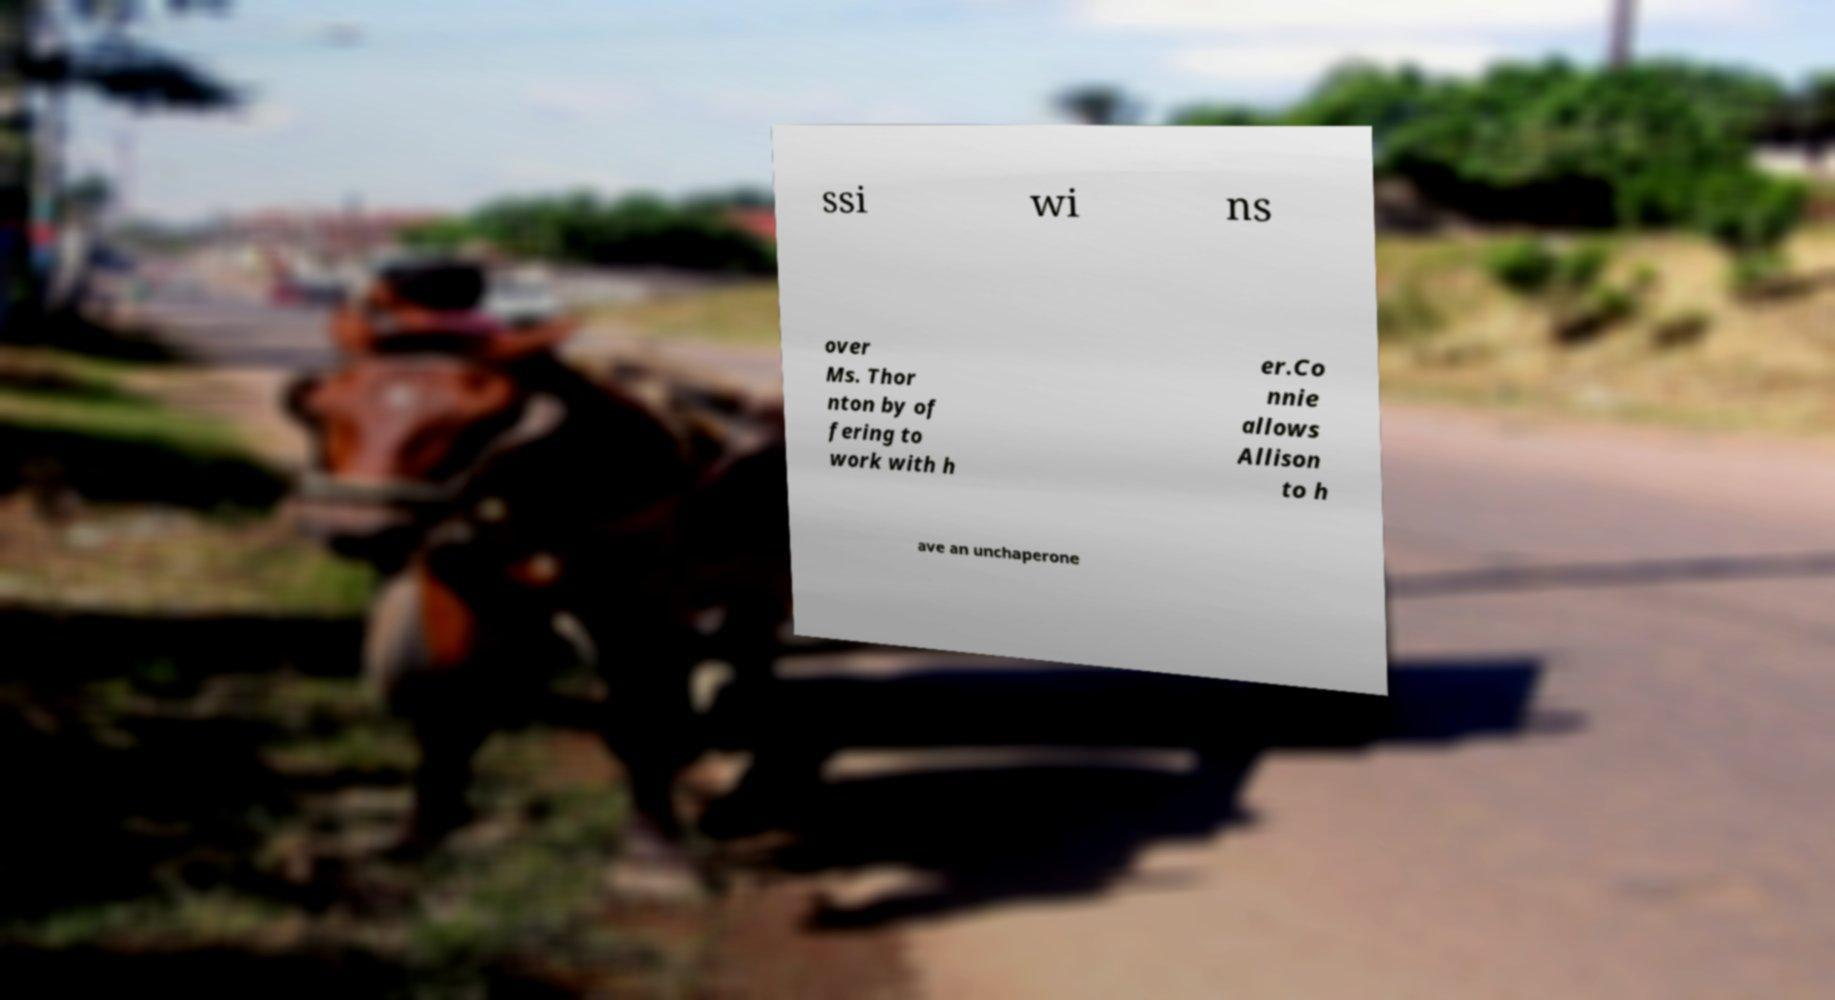Can you read and provide the text displayed in the image?This photo seems to have some interesting text. Can you extract and type it out for me? ssi wi ns over Ms. Thor nton by of fering to work with h er.Co nnie allows Allison to h ave an unchaperone 